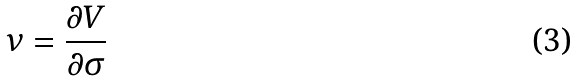Convert formula to latex. <formula><loc_0><loc_0><loc_500><loc_500>\nu = \frac { \partial V } { \partial \sigma }</formula> 